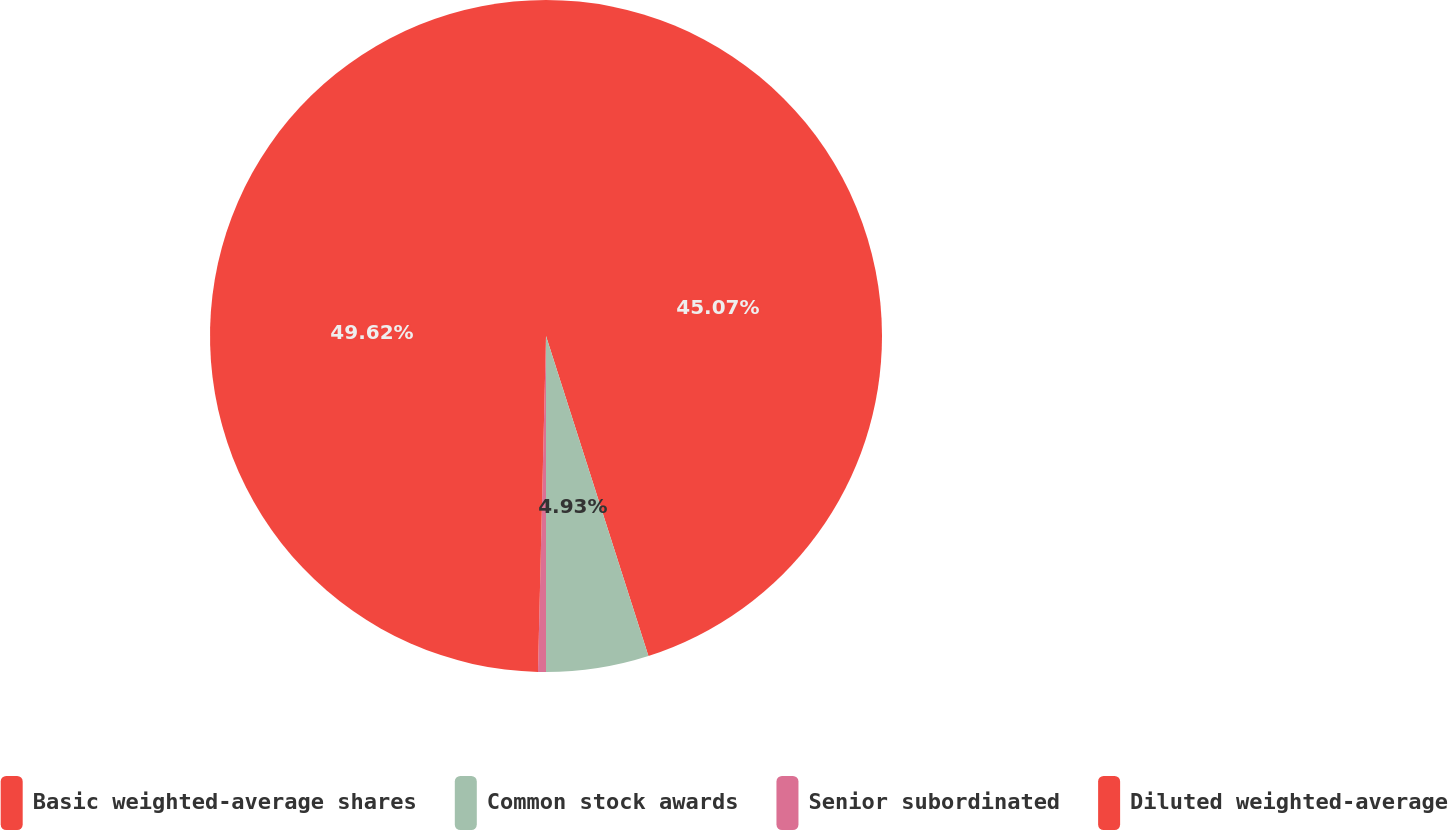Convert chart. <chart><loc_0><loc_0><loc_500><loc_500><pie_chart><fcel>Basic weighted-average shares<fcel>Common stock awards<fcel>Senior subordinated<fcel>Diluted weighted-average<nl><fcel>45.07%<fcel>4.93%<fcel>0.38%<fcel>49.62%<nl></chart> 